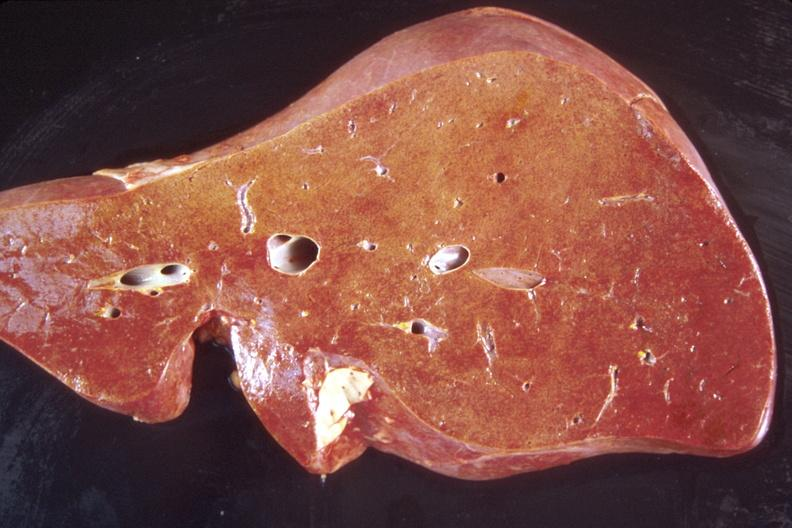does this image show liver, normal?
Answer the question using a single word or phrase. Yes 